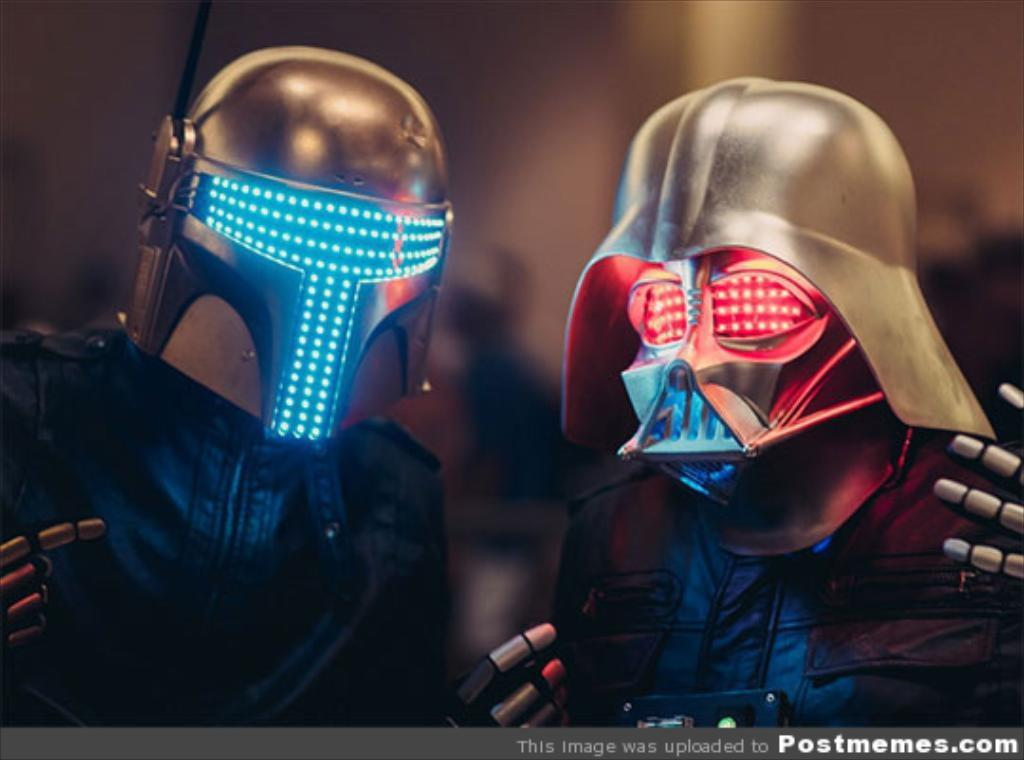How many persons are in the image? There are persons in the image. What are the persons wearing? The persons are wearing costumes and helmets. What feature can be seen on the helmets? There are lights on the helmets. Can you describe the background of the image? The background of the image is blurry. What type of reward can be seen on the school desk in the image? There is no mention of a reward, school, or desk in the image. The image features persons wearing costumes and helmets with lights, and the background is blurry. 